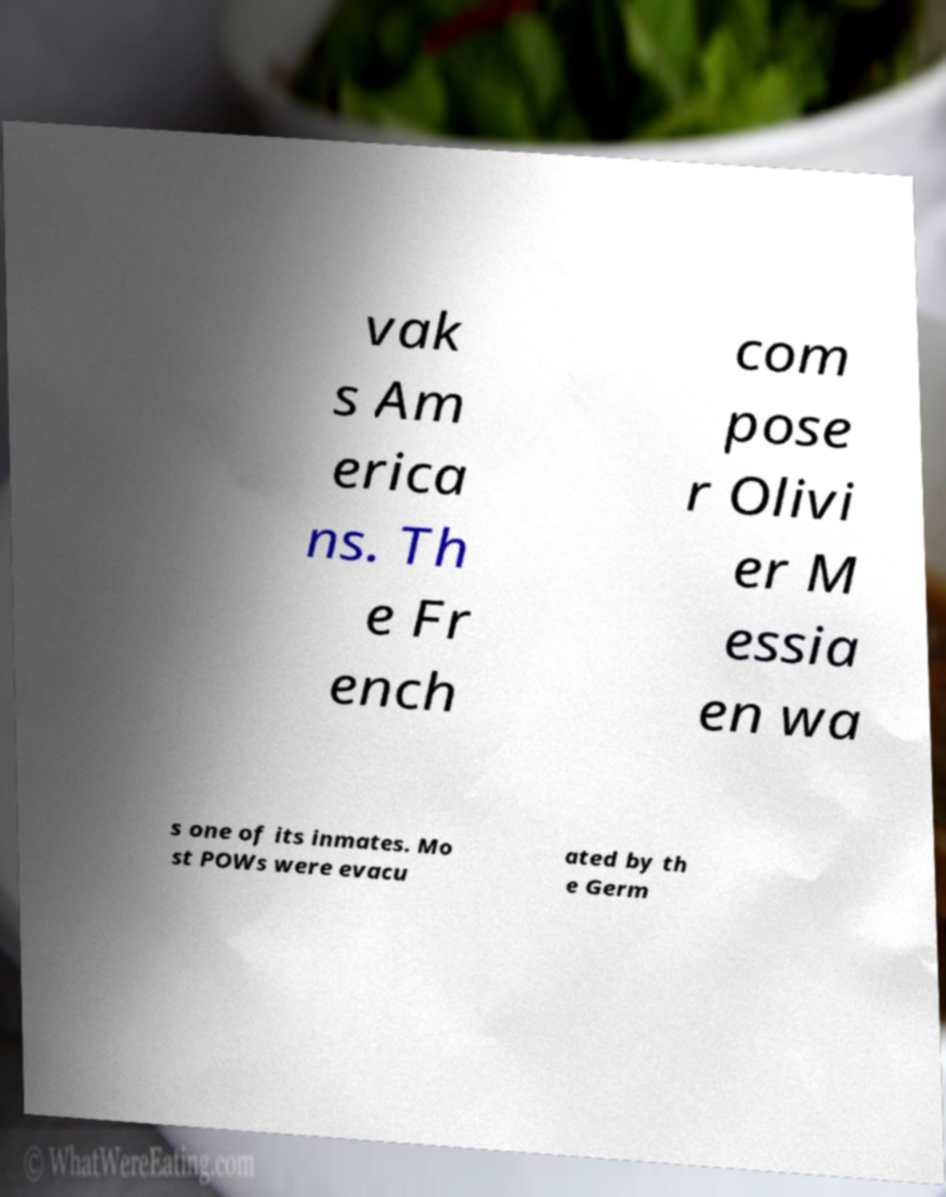Could you assist in decoding the text presented in this image and type it out clearly? vak s Am erica ns. Th e Fr ench com pose r Olivi er M essia en wa s one of its inmates. Mo st POWs were evacu ated by th e Germ 